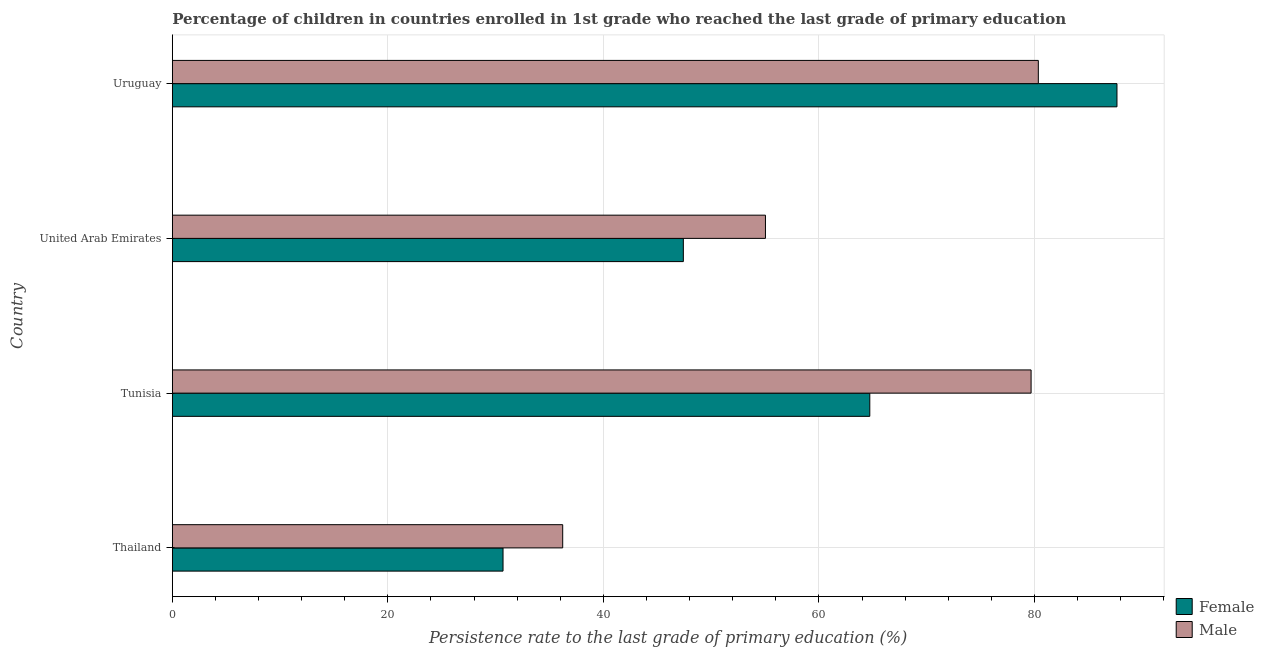How many groups of bars are there?
Give a very brief answer. 4. How many bars are there on the 1st tick from the bottom?
Offer a terse response. 2. What is the label of the 4th group of bars from the top?
Provide a short and direct response. Thailand. In how many cases, is the number of bars for a given country not equal to the number of legend labels?
Provide a succinct answer. 0. What is the persistence rate of female students in Thailand?
Your answer should be very brief. 30.69. Across all countries, what is the maximum persistence rate of male students?
Give a very brief answer. 80.36. Across all countries, what is the minimum persistence rate of female students?
Offer a terse response. 30.69. In which country was the persistence rate of male students maximum?
Keep it short and to the point. Uruguay. In which country was the persistence rate of male students minimum?
Provide a succinct answer. Thailand. What is the total persistence rate of female students in the graph?
Keep it short and to the point. 230.48. What is the difference between the persistence rate of male students in Tunisia and that in United Arab Emirates?
Ensure brevity in your answer.  24.65. What is the difference between the persistence rate of female students in Uruguay and the persistence rate of male students in Tunisia?
Your response must be concise. 7.97. What is the average persistence rate of female students per country?
Your response must be concise. 57.62. What is the difference between the persistence rate of female students and persistence rate of male students in United Arab Emirates?
Provide a succinct answer. -7.62. What is the ratio of the persistence rate of female students in Thailand to that in United Arab Emirates?
Your answer should be compact. 0.65. Is the persistence rate of female students in Thailand less than that in Uruguay?
Provide a succinct answer. Yes. What is the difference between the highest and the second highest persistence rate of female students?
Your response must be concise. 22.94. What is the difference between the highest and the lowest persistence rate of female students?
Give a very brief answer. 56.97. In how many countries, is the persistence rate of female students greater than the average persistence rate of female students taken over all countries?
Keep it short and to the point. 2. Is the sum of the persistence rate of male students in Thailand and United Arab Emirates greater than the maximum persistence rate of female students across all countries?
Your response must be concise. Yes. Are all the bars in the graph horizontal?
Give a very brief answer. Yes. Does the graph contain any zero values?
Offer a very short reply. No. How many legend labels are there?
Ensure brevity in your answer.  2. What is the title of the graph?
Make the answer very short. Percentage of children in countries enrolled in 1st grade who reached the last grade of primary education. What is the label or title of the X-axis?
Ensure brevity in your answer.  Persistence rate to the last grade of primary education (%). What is the label or title of the Y-axis?
Give a very brief answer. Country. What is the Persistence rate to the last grade of primary education (%) in Female in Thailand?
Keep it short and to the point. 30.69. What is the Persistence rate to the last grade of primary education (%) in Male in Thailand?
Provide a short and direct response. 36.22. What is the Persistence rate to the last grade of primary education (%) in Female in Tunisia?
Ensure brevity in your answer.  64.72. What is the Persistence rate to the last grade of primary education (%) in Male in Tunisia?
Provide a short and direct response. 79.69. What is the Persistence rate to the last grade of primary education (%) of Female in United Arab Emirates?
Provide a short and direct response. 47.42. What is the Persistence rate to the last grade of primary education (%) in Male in United Arab Emirates?
Keep it short and to the point. 55.04. What is the Persistence rate to the last grade of primary education (%) in Female in Uruguay?
Offer a very short reply. 87.66. What is the Persistence rate to the last grade of primary education (%) in Male in Uruguay?
Provide a short and direct response. 80.36. Across all countries, what is the maximum Persistence rate to the last grade of primary education (%) of Female?
Offer a terse response. 87.66. Across all countries, what is the maximum Persistence rate to the last grade of primary education (%) in Male?
Provide a succinct answer. 80.36. Across all countries, what is the minimum Persistence rate to the last grade of primary education (%) in Female?
Make the answer very short. 30.69. Across all countries, what is the minimum Persistence rate to the last grade of primary education (%) of Male?
Your answer should be very brief. 36.22. What is the total Persistence rate to the last grade of primary education (%) of Female in the graph?
Provide a succinct answer. 230.48. What is the total Persistence rate to the last grade of primary education (%) of Male in the graph?
Your answer should be very brief. 251.31. What is the difference between the Persistence rate to the last grade of primary education (%) in Female in Thailand and that in Tunisia?
Provide a short and direct response. -34.03. What is the difference between the Persistence rate to the last grade of primary education (%) in Male in Thailand and that in Tunisia?
Your response must be concise. -43.47. What is the difference between the Persistence rate to the last grade of primary education (%) in Female in Thailand and that in United Arab Emirates?
Ensure brevity in your answer.  -16.73. What is the difference between the Persistence rate to the last grade of primary education (%) of Male in Thailand and that in United Arab Emirates?
Offer a very short reply. -18.82. What is the difference between the Persistence rate to the last grade of primary education (%) in Female in Thailand and that in Uruguay?
Your answer should be very brief. -56.97. What is the difference between the Persistence rate to the last grade of primary education (%) in Male in Thailand and that in Uruguay?
Make the answer very short. -44.14. What is the difference between the Persistence rate to the last grade of primary education (%) of Female in Tunisia and that in United Arab Emirates?
Make the answer very short. 17.3. What is the difference between the Persistence rate to the last grade of primary education (%) of Male in Tunisia and that in United Arab Emirates?
Your answer should be very brief. 24.65. What is the difference between the Persistence rate to the last grade of primary education (%) of Female in Tunisia and that in Uruguay?
Ensure brevity in your answer.  -22.94. What is the difference between the Persistence rate to the last grade of primary education (%) of Male in Tunisia and that in Uruguay?
Offer a very short reply. -0.67. What is the difference between the Persistence rate to the last grade of primary education (%) in Female in United Arab Emirates and that in Uruguay?
Your answer should be compact. -40.24. What is the difference between the Persistence rate to the last grade of primary education (%) of Male in United Arab Emirates and that in Uruguay?
Give a very brief answer. -25.32. What is the difference between the Persistence rate to the last grade of primary education (%) in Female in Thailand and the Persistence rate to the last grade of primary education (%) in Male in Tunisia?
Provide a short and direct response. -49. What is the difference between the Persistence rate to the last grade of primary education (%) in Female in Thailand and the Persistence rate to the last grade of primary education (%) in Male in United Arab Emirates?
Ensure brevity in your answer.  -24.35. What is the difference between the Persistence rate to the last grade of primary education (%) of Female in Thailand and the Persistence rate to the last grade of primary education (%) of Male in Uruguay?
Your answer should be very brief. -49.67. What is the difference between the Persistence rate to the last grade of primary education (%) in Female in Tunisia and the Persistence rate to the last grade of primary education (%) in Male in United Arab Emirates?
Make the answer very short. 9.68. What is the difference between the Persistence rate to the last grade of primary education (%) in Female in Tunisia and the Persistence rate to the last grade of primary education (%) in Male in Uruguay?
Provide a short and direct response. -15.64. What is the difference between the Persistence rate to the last grade of primary education (%) in Female in United Arab Emirates and the Persistence rate to the last grade of primary education (%) in Male in Uruguay?
Provide a short and direct response. -32.94. What is the average Persistence rate to the last grade of primary education (%) of Female per country?
Your response must be concise. 57.62. What is the average Persistence rate to the last grade of primary education (%) in Male per country?
Keep it short and to the point. 62.83. What is the difference between the Persistence rate to the last grade of primary education (%) of Female and Persistence rate to the last grade of primary education (%) of Male in Thailand?
Make the answer very short. -5.54. What is the difference between the Persistence rate to the last grade of primary education (%) in Female and Persistence rate to the last grade of primary education (%) in Male in Tunisia?
Offer a terse response. -14.97. What is the difference between the Persistence rate to the last grade of primary education (%) of Female and Persistence rate to the last grade of primary education (%) of Male in United Arab Emirates?
Offer a very short reply. -7.62. What is the difference between the Persistence rate to the last grade of primary education (%) in Female and Persistence rate to the last grade of primary education (%) in Male in Uruguay?
Keep it short and to the point. 7.3. What is the ratio of the Persistence rate to the last grade of primary education (%) of Female in Thailand to that in Tunisia?
Provide a short and direct response. 0.47. What is the ratio of the Persistence rate to the last grade of primary education (%) of Male in Thailand to that in Tunisia?
Provide a succinct answer. 0.45. What is the ratio of the Persistence rate to the last grade of primary education (%) of Female in Thailand to that in United Arab Emirates?
Provide a succinct answer. 0.65. What is the ratio of the Persistence rate to the last grade of primary education (%) of Male in Thailand to that in United Arab Emirates?
Your answer should be very brief. 0.66. What is the ratio of the Persistence rate to the last grade of primary education (%) of Female in Thailand to that in Uruguay?
Make the answer very short. 0.35. What is the ratio of the Persistence rate to the last grade of primary education (%) in Male in Thailand to that in Uruguay?
Keep it short and to the point. 0.45. What is the ratio of the Persistence rate to the last grade of primary education (%) of Female in Tunisia to that in United Arab Emirates?
Your answer should be very brief. 1.36. What is the ratio of the Persistence rate to the last grade of primary education (%) in Male in Tunisia to that in United Arab Emirates?
Provide a succinct answer. 1.45. What is the ratio of the Persistence rate to the last grade of primary education (%) in Female in Tunisia to that in Uruguay?
Offer a terse response. 0.74. What is the ratio of the Persistence rate to the last grade of primary education (%) of Female in United Arab Emirates to that in Uruguay?
Give a very brief answer. 0.54. What is the ratio of the Persistence rate to the last grade of primary education (%) of Male in United Arab Emirates to that in Uruguay?
Your answer should be compact. 0.68. What is the difference between the highest and the second highest Persistence rate to the last grade of primary education (%) in Female?
Provide a short and direct response. 22.94. What is the difference between the highest and the second highest Persistence rate to the last grade of primary education (%) in Male?
Ensure brevity in your answer.  0.67. What is the difference between the highest and the lowest Persistence rate to the last grade of primary education (%) in Female?
Provide a succinct answer. 56.97. What is the difference between the highest and the lowest Persistence rate to the last grade of primary education (%) of Male?
Provide a short and direct response. 44.14. 